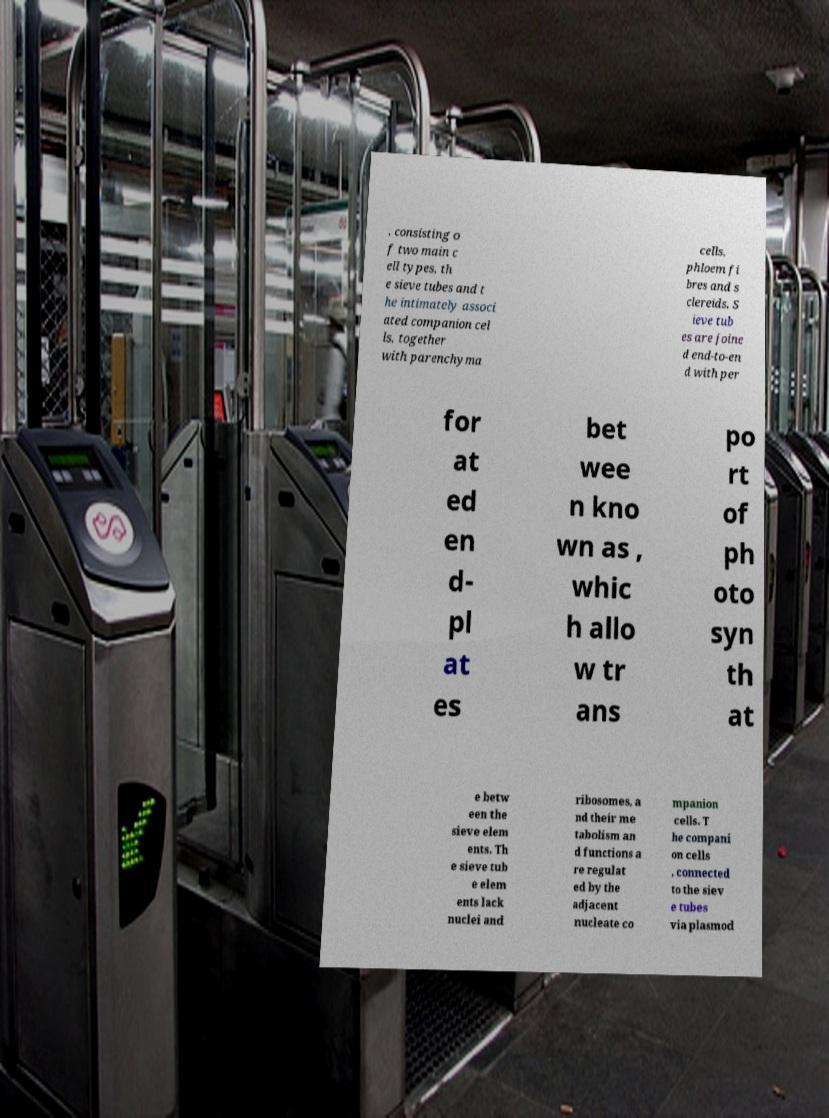Could you extract and type out the text from this image? , consisting o f two main c ell types, th e sieve tubes and t he intimately associ ated companion cel ls, together with parenchyma cells, phloem fi bres and s clereids. S ieve tub es are joine d end-to-en d with per for at ed en d- pl at es bet wee n kno wn as , whic h allo w tr ans po rt of ph oto syn th at e betw een the sieve elem ents. Th e sieve tub e elem ents lack nuclei and ribosomes, a nd their me tabolism an d functions a re regulat ed by the adjacent nucleate co mpanion cells. T he compani on cells , connected to the siev e tubes via plasmod 